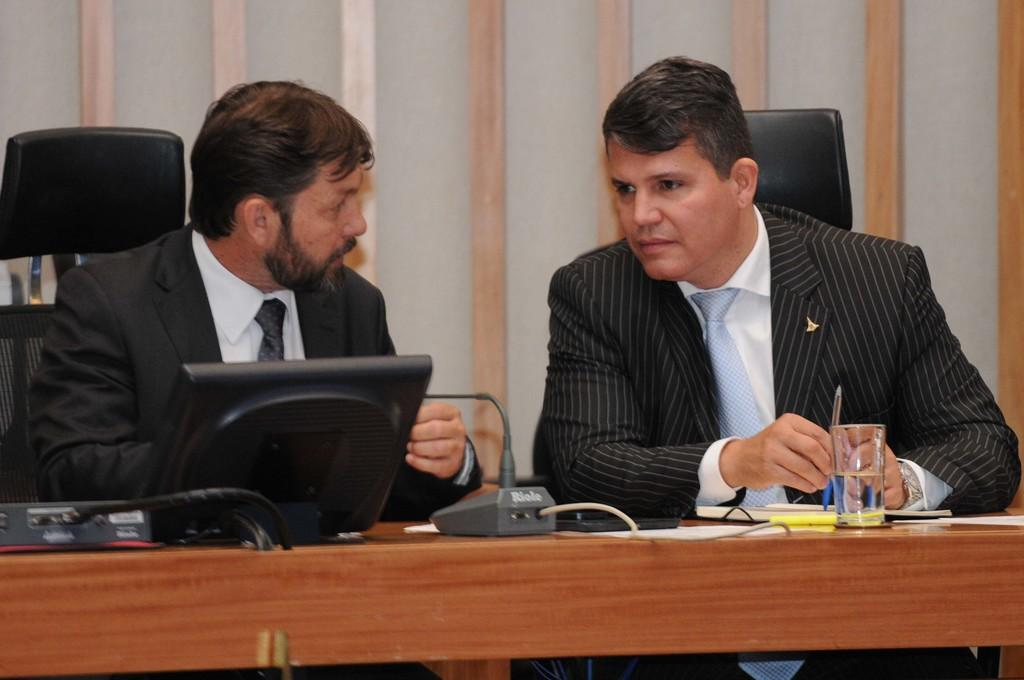How many men are present in the image? There are two men in the image. What are the men doing in the image? The men are sitting on chairs in the image. What type of clothing are the men wearing? The men are wearing blazers in the image. What items can be seen on the desktop in the image? There are papers and a book on the desktop in the image. What is the glass used for in the image? The glass might be used for drinking or holding a beverage in the image. What is visible in the background of the image? There is a wall in the background of the image. What type of powder is being used by the men in the image? There is no powder present in the image; the men are wearing blazers and sitting on chairs. Is there a crate visible in the image? No, there is no crate present in the image. 